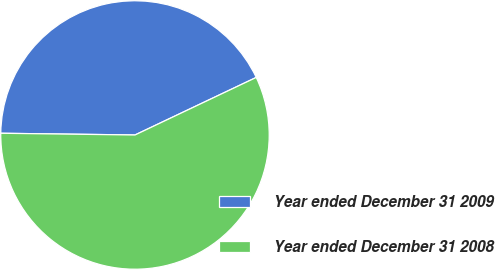Convert chart. <chart><loc_0><loc_0><loc_500><loc_500><pie_chart><fcel>Year ended December 31 2009<fcel>Year ended December 31 2008<nl><fcel>42.74%<fcel>57.26%<nl></chart> 